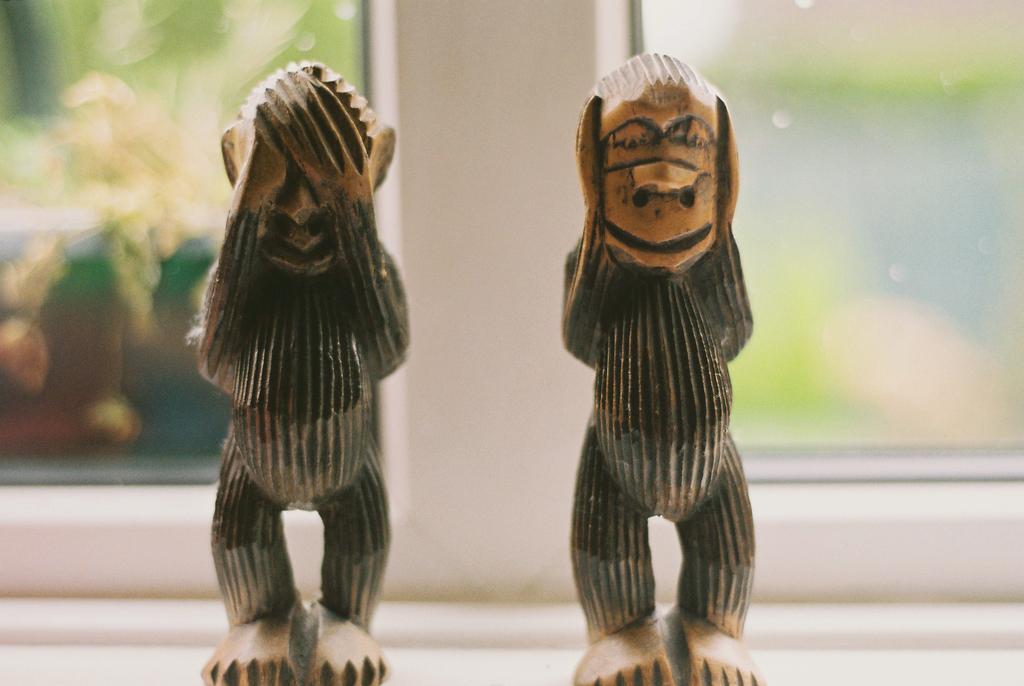Could you give a brief overview of what you see in this image? In the center of the image we can see toy statues. In the background there are windows. 